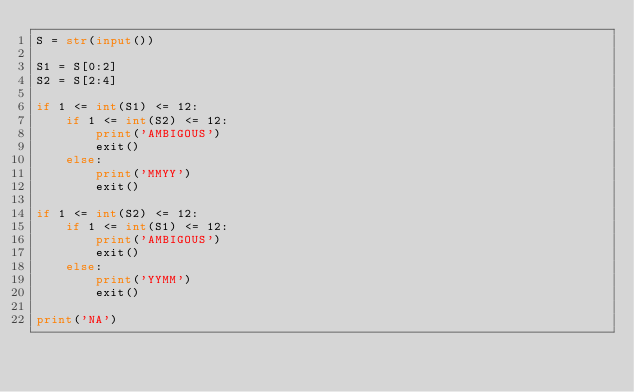<code> <loc_0><loc_0><loc_500><loc_500><_Python_>S = str(input())

S1 = S[0:2]
S2 = S[2:4]

if 1 <= int(S1) <= 12:
    if 1 <= int(S2) <= 12:
        print('AMBIGOUS')
        exit()
    else:
        print('MMYY')
        exit()

if 1 <= int(S2) <= 12:
    if 1 <= int(S1) <= 12:
        print('AMBIGOUS')
        exit()
    else:
        print('YYMM')
        exit()

print('NA')</code> 